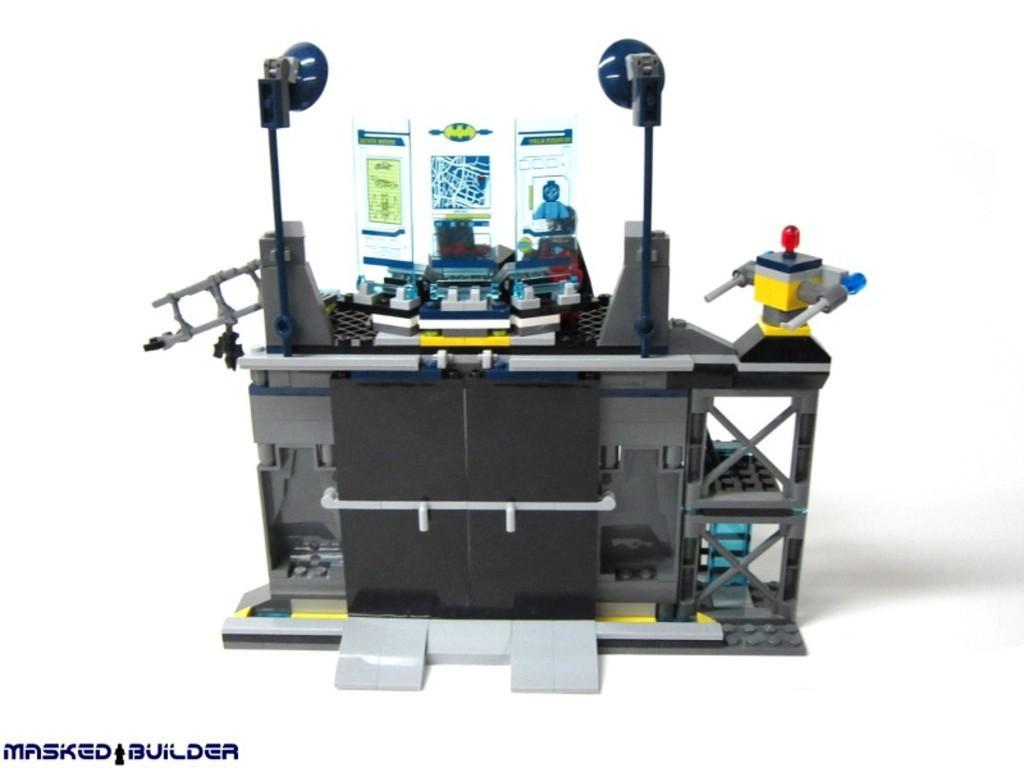In one or two sentences, can you explain what this image depicts? In this image we can see some toys placed on the surface. At the bottom we can see some text. 